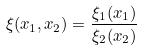Convert formula to latex. <formula><loc_0><loc_0><loc_500><loc_500>\xi ( x _ { 1 } , x _ { 2 } ) = \frac { \xi _ { 1 } ( x _ { 1 } ) } { \xi _ { 2 } ( x _ { 2 } ) }</formula> 